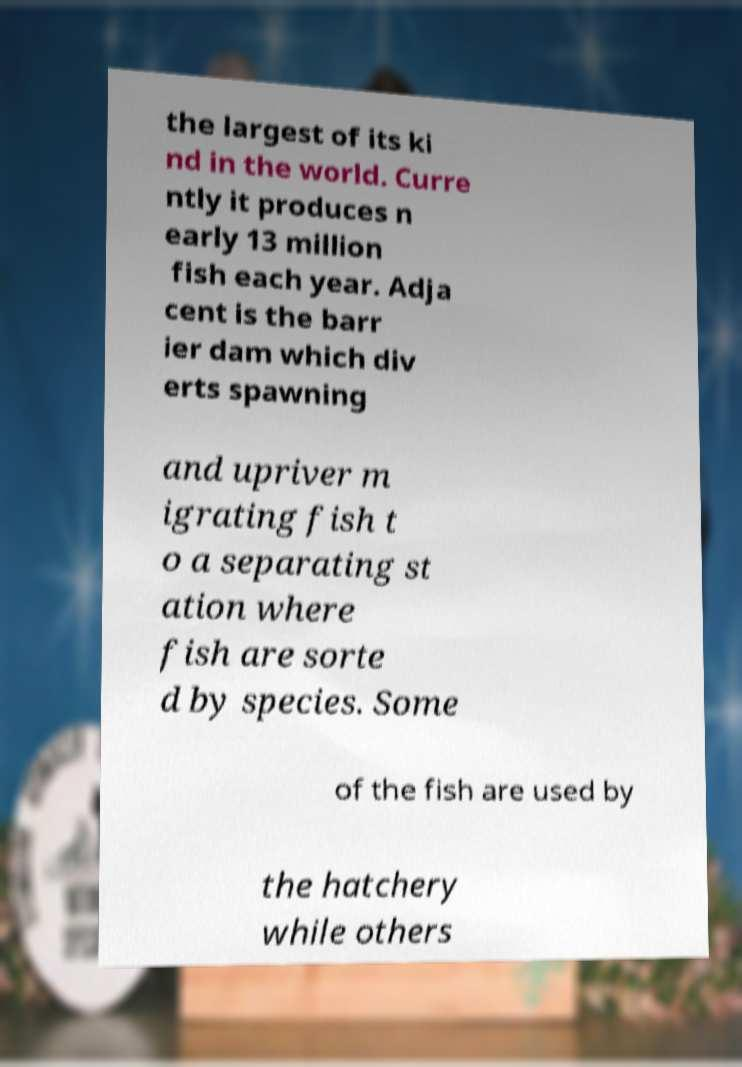Could you assist in decoding the text presented in this image and type it out clearly? the largest of its ki nd in the world. Curre ntly it produces n early 13 million fish each year. Adja cent is the barr ier dam which div erts spawning and upriver m igrating fish t o a separating st ation where fish are sorte d by species. Some of the fish are used by the hatchery while others 